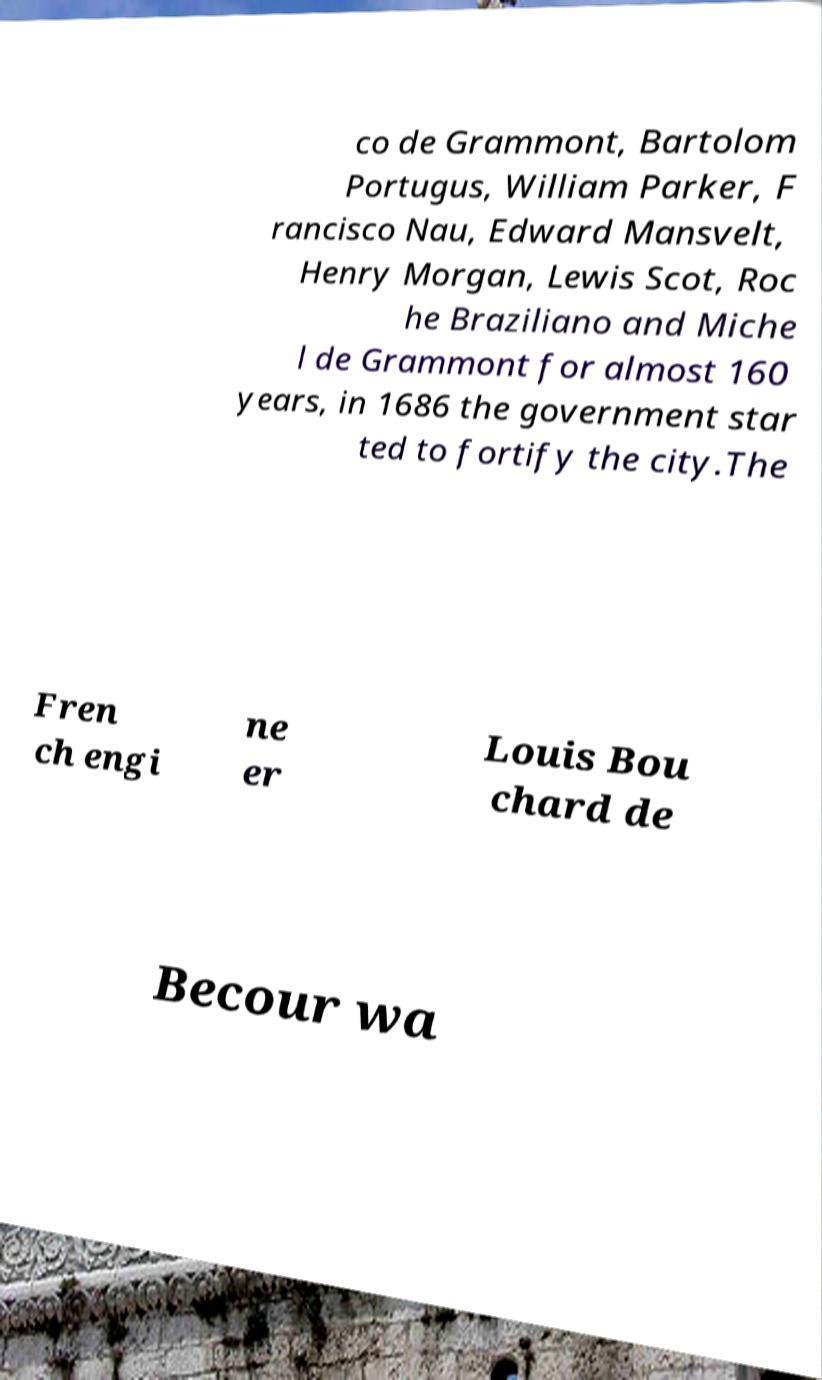Can you read and provide the text displayed in the image?This photo seems to have some interesting text. Can you extract and type it out for me? co de Grammont, Bartolom Portugus, William Parker, F rancisco Nau, Edward Mansvelt, Henry Morgan, Lewis Scot, Roc he Braziliano and Miche l de Grammont for almost 160 years, in 1686 the government star ted to fortify the city.The Fren ch engi ne er Louis Bou chard de Becour wa 